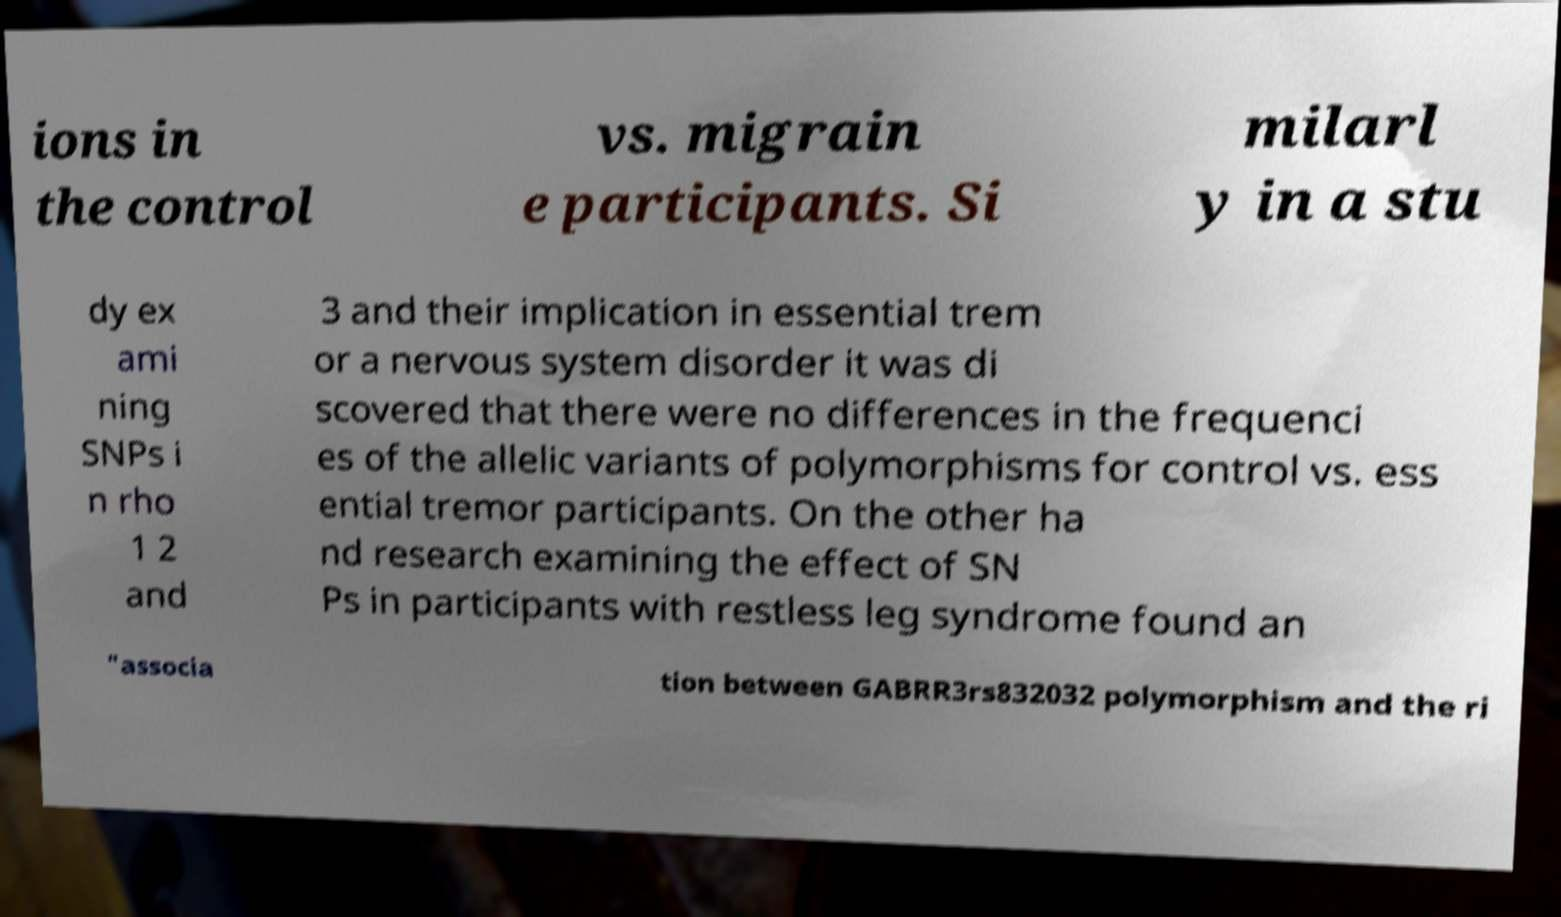There's text embedded in this image that I need extracted. Can you transcribe it verbatim? ions in the control vs. migrain e participants. Si milarl y in a stu dy ex ami ning SNPs i n rho 1 2 and 3 and their implication in essential trem or a nervous system disorder it was di scovered that there were no differences in the frequenci es of the allelic variants of polymorphisms for control vs. ess ential tremor participants. On the other ha nd research examining the effect of SN Ps in participants with restless leg syndrome found an "associa tion between GABRR3rs832032 polymorphism and the ri 